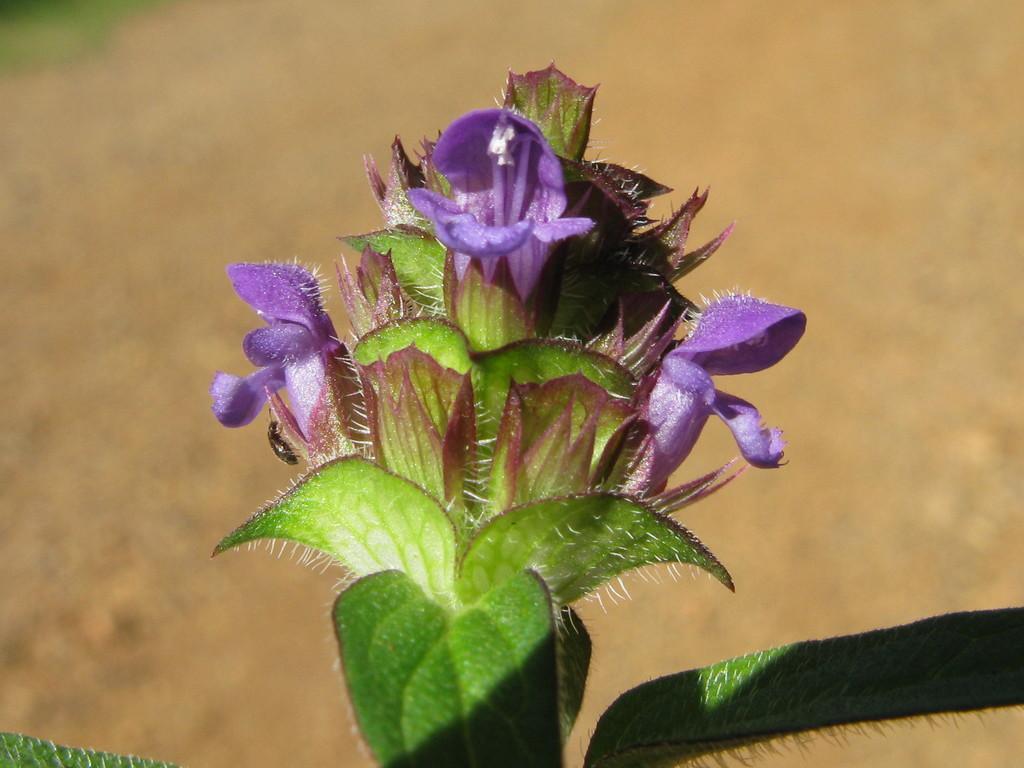Can you describe this image briefly? In the center of the image there is a plant. 